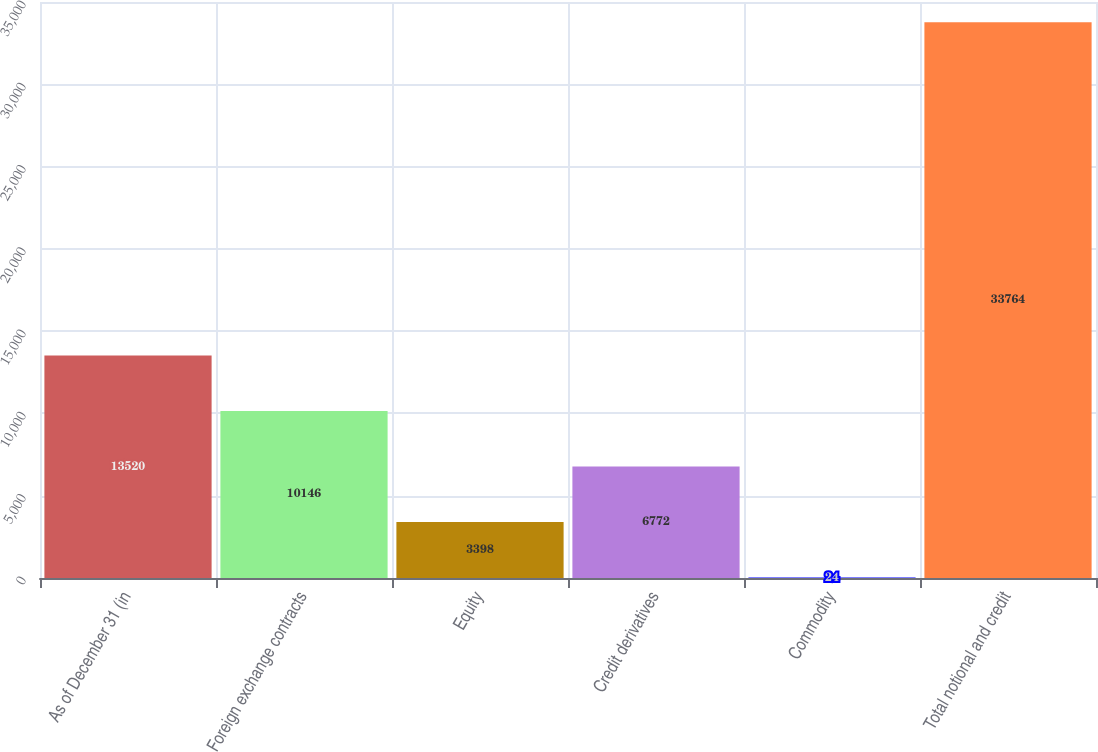<chart> <loc_0><loc_0><loc_500><loc_500><bar_chart><fcel>As of December 31 (in<fcel>Foreign exchange contracts<fcel>Equity<fcel>Credit derivatives<fcel>Commodity<fcel>Total notional and credit<nl><fcel>13520<fcel>10146<fcel>3398<fcel>6772<fcel>24<fcel>33764<nl></chart> 